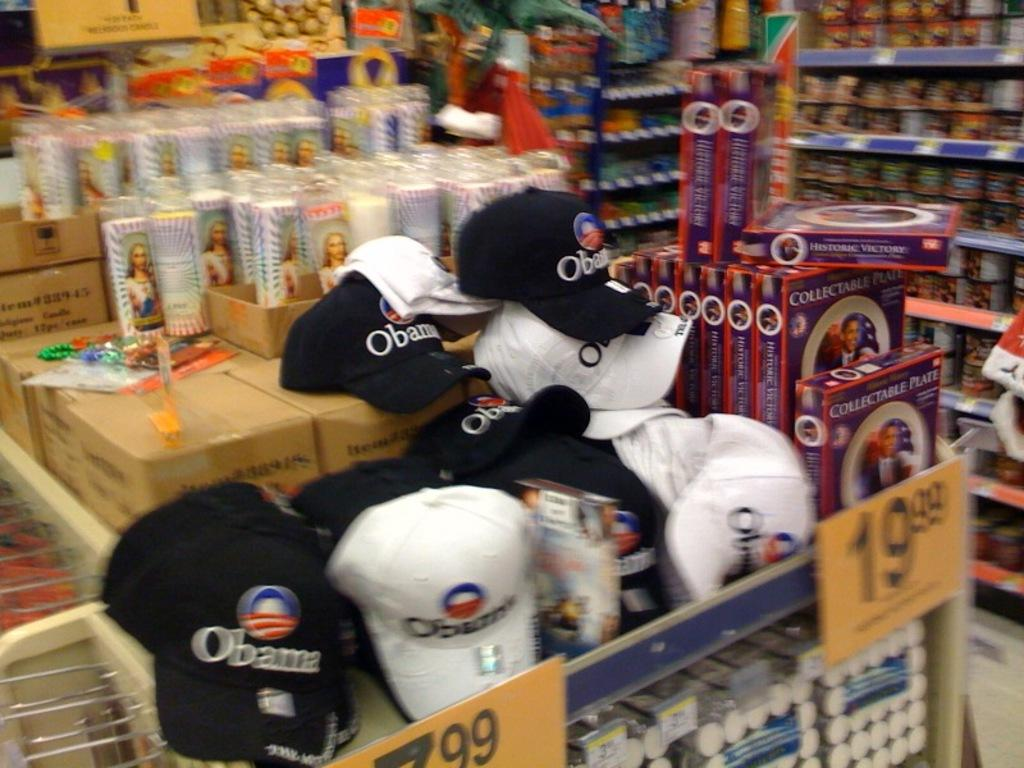<image>
Summarize the visual content of the image. A bin full of collectable including hats with name Obama on them. 